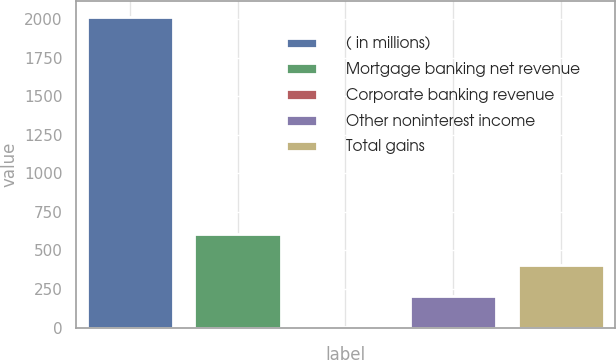Convert chart. <chart><loc_0><loc_0><loc_500><loc_500><bar_chart><fcel>( in millions)<fcel>Mortgage banking net revenue<fcel>Corporate banking revenue<fcel>Other noninterest income<fcel>Total gains<nl><fcel>2014<fcel>605.6<fcel>2<fcel>203.2<fcel>404.4<nl></chart> 